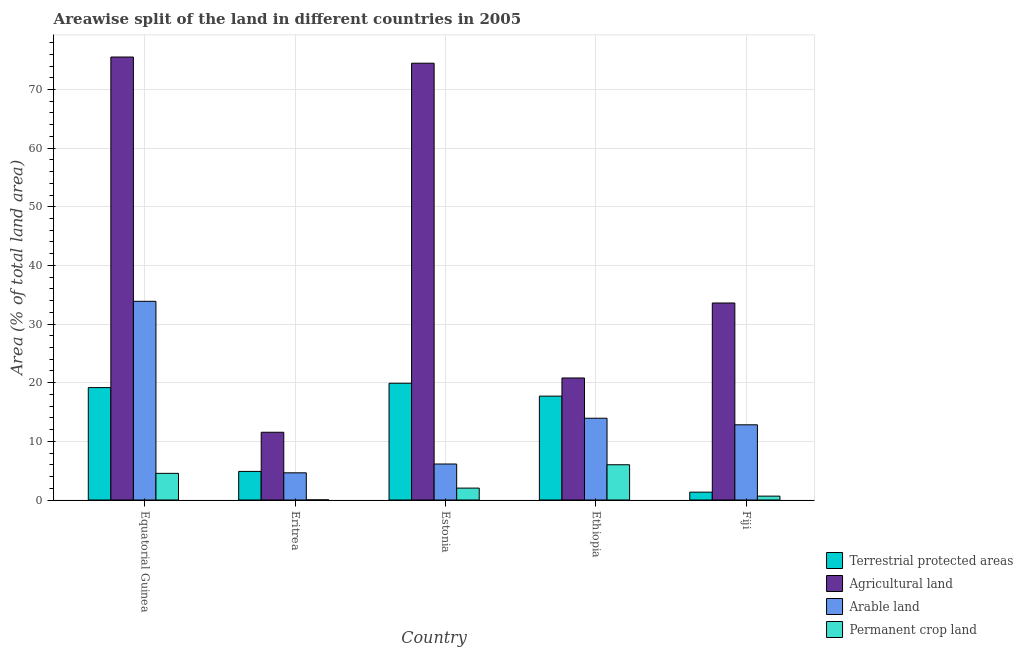How many different coloured bars are there?
Your response must be concise. 4. How many groups of bars are there?
Provide a succinct answer. 5. Are the number of bars on each tick of the X-axis equal?
Give a very brief answer. Yes. What is the label of the 4th group of bars from the left?
Give a very brief answer. Ethiopia. In how many cases, is the number of bars for a given country not equal to the number of legend labels?
Your response must be concise. 0. What is the percentage of area under permanent crop land in Fiji?
Offer a very short reply. 0.66. Across all countries, what is the maximum percentage of area under arable land?
Provide a short and direct response. 33.88. Across all countries, what is the minimum percentage of area under arable land?
Provide a short and direct response. 4.63. In which country was the percentage of land under terrestrial protection maximum?
Offer a terse response. Estonia. In which country was the percentage of area under permanent crop land minimum?
Provide a short and direct response. Eritrea. What is the total percentage of area under agricultural land in the graph?
Offer a terse response. 215.95. What is the difference between the percentage of area under agricultural land in Equatorial Guinea and that in Eritrea?
Your answer should be compact. 63.98. What is the difference between the percentage of area under permanent crop land in Fiji and the percentage of area under arable land in Equatorial Guinea?
Keep it short and to the point. -33.22. What is the average percentage of land under terrestrial protection per country?
Offer a terse response. 12.6. What is the difference between the percentage of area under arable land and percentage of area under agricultural land in Eritrea?
Give a very brief answer. -6.92. What is the ratio of the percentage of land under terrestrial protection in Eritrea to that in Ethiopia?
Your answer should be very brief. 0.28. Is the difference between the percentage of area under arable land in Estonia and Ethiopia greater than the difference between the percentage of area under agricultural land in Estonia and Ethiopia?
Offer a very short reply. No. What is the difference between the highest and the second highest percentage of area under arable land?
Keep it short and to the point. 19.94. What is the difference between the highest and the lowest percentage of area under permanent crop land?
Give a very brief answer. 6. In how many countries, is the percentage of area under permanent crop land greater than the average percentage of area under permanent crop land taken over all countries?
Your response must be concise. 2. What does the 4th bar from the left in Ethiopia represents?
Offer a terse response. Permanent crop land. What does the 3rd bar from the right in Eritrea represents?
Make the answer very short. Agricultural land. Is it the case that in every country, the sum of the percentage of land under terrestrial protection and percentage of area under agricultural land is greater than the percentage of area under arable land?
Keep it short and to the point. Yes. How many countries are there in the graph?
Keep it short and to the point. 5. Are the values on the major ticks of Y-axis written in scientific E-notation?
Your response must be concise. No. Does the graph contain any zero values?
Keep it short and to the point. No. How are the legend labels stacked?
Give a very brief answer. Vertical. What is the title of the graph?
Offer a terse response. Areawise split of the land in different countries in 2005. Does "United Kingdom" appear as one of the legend labels in the graph?
Your answer should be very brief. No. What is the label or title of the Y-axis?
Offer a very short reply. Area (% of total land area). What is the Area (% of total land area) of Terrestrial protected areas in Equatorial Guinea?
Your answer should be very brief. 19.16. What is the Area (% of total land area) of Agricultural land in Equatorial Guinea?
Offer a terse response. 75.53. What is the Area (% of total land area) in Arable land in Equatorial Guinea?
Make the answer very short. 33.88. What is the Area (% of total land area) in Permanent crop land in Equatorial Guinea?
Keep it short and to the point. 4.54. What is the Area (% of total land area) in Terrestrial protected areas in Eritrea?
Offer a terse response. 4.87. What is the Area (% of total land area) of Agricultural land in Eritrea?
Your response must be concise. 11.55. What is the Area (% of total land area) in Arable land in Eritrea?
Your answer should be very brief. 4.63. What is the Area (% of total land area) in Permanent crop land in Eritrea?
Make the answer very short. 0.01. What is the Area (% of total land area) in Terrestrial protected areas in Estonia?
Keep it short and to the point. 19.91. What is the Area (% of total land area) in Agricultural land in Estonia?
Offer a terse response. 74.48. What is the Area (% of total land area) of Arable land in Estonia?
Provide a succinct answer. 6.14. What is the Area (% of total land area) of Permanent crop land in Estonia?
Offer a terse response. 2.03. What is the Area (% of total land area) of Terrestrial protected areas in Ethiopia?
Offer a very short reply. 17.71. What is the Area (% of total land area) of Agricultural land in Ethiopia?
Ensure brevity in your answer.  20.81. What is the Area (% of total land area) of Arable land in Ethiopia?
Offer a very short reply. 13.94. What is the Area (% of total land area) in Permanent crop land in Ethiopia?
Your answer should be compact. 6.01. What is the Area (% of total land area) in Terrestrial protected areas in Fiji?
Your answer should be compact. 1.34. What is the Area (% of total land area) of Agricultural land in Fiji?
Keep it short and to the point. 33.59. What is the Area (% of total land area) of Arable land in Fiji?
Ensure brevity in your answer.  12.82. What is the Area (% of total land area) in Permanent crop land in Fiji?
Provide a succinct answer. 0.66. Across all countries, what is the maximum Area (% of total land area) of Terrestrial protected areas?
Make the answer very short. 19.91. Across all countries, what is the maximum Area (% of total land area) in Agricultural land?
Offer a terse response. 75.53. Across all countries, what is the maximum Area (% of total land area) in Arable land?
Give a very brief answer. 33.88. Across all countries, what is the maximum Area (% of total land area) in Permanent crop land?
Keep it short and to the point. 6.01. Across all countries, what is the minimum Area (% of total land area) in Terrestrial protected areas?
Your response must be concise. 1.34. Across all countries, what is the minimum Area (% of total land area) of Agricultural land?
Give a very brief answer. 11.55. Across all countries, what is the minimum Area (% of total land area) in Arable land?
Your answer should be compact. 4.63. Across all countries, what is the minimum Area (% of total land area) in Permanent crop land?
Your response must be concise. 0.01. What is the total Area (% of total land area) in Terrestrial protected areas in the graph?
Your response must be concise. 62.99. What is the total Area (% of total land area) in Agricultural land in the graph?
Make the answer very short. 215.95. What is the total Area (% of total land area) in Arable land in the graph?
Offer a terse response. 71.42. What is the total Area (% of total land area) of Permanent crop land in the graph?
Give a very brief answer. 13.26. What is the difference between the Area (% of total land area) of Terrestrial protected areas in Equatorial Guinea and that in Eritrea?
Offer a terse response. 14.29. What is the difference between the Area (% of total land area) in Agricultural land in Equatorial Guinea and that in Eritrea?
Keep it short and to the point. 63.98. What is the difference between the Area (% of total land area) in Arable land in Equatorial Guinea and that in Eritrea?
Offer a terse response. 29.25. What is the difference between the Area (% of total land area) of Permanent crop land in Equatorial Guinea and that in Eritrea?
Your answer should be very brief. 4.53. What is the difference between the Area (% of total land area) of Terrestrial protected areas in Equatorial Guinea and that in Estonia?
Your response must be concise. -0.74. What is the difference between the Area (% of total land area) of Agricultural land in Equatorial Guinea and that in Estonia?
Provide a succinct answer. 1.06. What is the difference between the Area (% of total land area) of Arable land in Equatorial Guinea and that in Estonia?
Your answer should be compact. 27.74. What is the difference between the Area (% of total land area) in Permanent crop land in Equatorial Guinea and that in Estonia?
Your response must be concise. 2.51. What is the difference between the Area (% of total land area) in Terrestrial protected areas in Equatorial Guinea and that in Ethiopia?
Provide a succinct answer. 1.45. What is the difference between the Area (% of total land area) in Agricultural land in Equatorial Guinea and that in Ethiopia?
Ensure brevity in your answer.  54.72. What is the difference between the Area (% of total land area) in Arable land in Equatorial Guinea and that in Ethiopia?
Keep it short and to the point. 19.94. What is the difference between the Area (% of total land area) of Permanent crop land in Equatorial Guinea and that in Ethiopia?
Provide a short and direct response. -1.47. What is the difference between the Area (% of total land area) in Terrestrial protected areas in Equatorial Guinea and that in Fiji?
Make the answer very short. 17.83. What is the difference between the Area (% of total land area) of Agricultural land in Equatorial Guinea and that in Fiji?
Provide a succinct answer. 41.94. What is the difference between the Area (% of total land area) in Arable land in Equatorial Guinea and that in Fiji?
Offer a terse response. 21.06. What is the difference between the Area (% of total land area) of Permanent crop land in Equatorial Guinea and that in Fiji?
Your answer should be compact. 3.88. What is the difference between the Area (% of total land area) in Terrestrial protected areas in Eritrea and that in Estonia?
Give a very brief answer. -15.03. What is the difference between the Area (% of total land area) of Agricultural land in Eritrea and that in Estonia?
Your answer should be compact. -62.92. What is the difference between the Area (% of total land area) of Arable land in Eritrea and that in Estonia?
Keep it short and to the point. -1.5. What is the difference between the Area (% of total land area) of Permanent crop land in Eritrea and that in Estonia?
Your response must be concise. -2.01. What is the difference between the Area (% of total land area) of Terrestrial protected areas in Eritrea and that in Ethiopia?
Make the answer very short. -12.84. What is the difference between the Area (% of total land area) in Agricultural land in Eritrea and that in Ethiopia?
Keep it short and to the point. -9.26. What is the difference between the Area (% of total land area) in Arable land in Eritrea and that in Ethiopia?
Provide a short and direct response. -9.31. What is the difference between the Area (% of total land area) of Permanent crop land in Eritrea and that in Ethiopia?
Offer a terse response. -6. What is the difference between the Area (% of total land area) of Terrestrial protected areas in Eritrea and that in Fiji?
Offer a terse response. 3.54. What is the difference between the Area (% of total land area) in Agricultural land in Eritrea and that in Fiji?
Provide a short and direct response. -22.04. What is the difference between the Area (% of total land area) in Arable land in Eritrea and that in Fiji?
Make the answer very short. -8.19. What is the difference between the Area (% of total land area) of Permanent crop land in Eritrea and that in Fiji?
Your answer should be very brief. -0.65. What is the difference between the Area (% of total land area) in Terrestrial protected areas in Estonia and that in Ethiopia?
Your answer should be very brief. 2.2. What is the difference between the Area (% of total land area) in Agricultural land in Estonia and that in Ethiopia?
Keep it short and to the point. 53.67. What is the difference between the Area (% of total land area) of Arable land in Estonia and that in Ethiopia?
Provide a short and direct response. -7.8. What is the difference between the Area (% of total land area) of Permanent crop land in Estonia and that in Ethiopia?
Your answer should be very brief. -3.98. What is the difference between the Area (% of total land area) of Terrestrial protected areas in Estonia and that in Fiji?
Ensure brevity in your answer.  18.57. What is the difference between the Area (% of total land area) of Agricultural land in Estonia and that in Fiji?
Provide a short and direct response. 40.88. What is the difference between the Area (% of total land area) in Arable land in Estonia and that in Fiji?
Provide a succinct answer. -6.68. What is the difference between the Area (% of total land area) in Permanent crop land in Estonia and that in Fiji?
Offer a terse response. 1.37. What is the difference between the Area (% of total land area) in Terrestrial protected areas in Ethiopia and that in Fiji?
Offer a very short reply. 16.37. What is the difference between the Area (% of total land area) in Agricultural land in Ethiopia and that in Fiji?
Your answer should be compact. -12.78. What is the difference between the Area (% of total land area) in Arable land in Ethiopia and that in Fiji?
Your answer should be compact. 1.12. What is the difference between the Area (% of total land area) in Permanent crop land in Ethiopia and that in Fiji?
Make the answer very short. 5.35. What is the difference between the Area (% of total land area) in Terrestrial protected areas in Equatorial Guinea and the Area (% of total land area) in Agricultural land in Eritrea?
Your answer should be very brief. 7.61. What is the difference between the Area (% of total land area) of Terrestrial protected areas in Equatorial Guinea and the Area (% of total land area) of Arable land in Eritrea?
Provide a short and direct response. 14.53. What is the difference between the Area (% of total land area) of Terrestrial protected areas in Equatorial Guinea and the Area (% of total land area) of Permanent crop land in Eritrea?
Make the answer very short. 19.15. What is the difference between the Area (% of total land area) in Agricultural land in Equatorial Guinea and the Area (% of total land area) in Arable land in Eritrea?
Keep it short and to the point. 70.9. What is the difference between the Area (% of total land area) in Agricultural land in Equatorial Guinea and the Area (% of total land area) in Permanent crop land in Eritrea?
Make the answer very short. 75.52. What is the difference between the Area (% of total land area) in Arable land in Equatorial Guinea and the Area (% of total land area) in Permanent crop land in Eritrea?
Offer a terse response. 33.87. What is the difference between the Area (% of total land area) in Terrestrial protected areas in Equatorial Guinea and the Area (% of total land area) in Agricultural land in Estonia?
Offer a terse response. -55.31. What is the difference between the Area (% of total land area) of Terrestrial protected areas in Equatorial Guinea and the Area (% of total land area) of Arable land in Estonia?
Offer a terse response. 13.03. What is the difference between the Area (% of total land area) of Terrestrial protected areas in Equatorial Guinea and the Area (% of total land area) of Permanent crop land in Estonia?
Your answer should be compact. 17.14. What is the difference between the Area (% of total land area) in Agricultural land in Equatorial Guinea and the Area (% of total land area) in Arable land in Estonia?
Provide a succinct answer. 69.39. What is the difference between the Area (% of total land area) of Agricultural land in Equatorial Guinea and the Area (% of total land area) of Permanent crop land in Estonia?
Offer a very short reply. 73.5. What is the difference between the Area (% of total land area) of Arable land in Equatorial Guinea and the Area (% of total land area) of Permanent crop land in Estonia?
Your answer should be compact. 31.85. What is the difference between the Area (% of total land area) in Terrestrial protected areas in Equatorial Guinea and the Area (% of total land area) in Agricultural land in Ethiopia?
Your answer should be very brief. -1.64. What is the difference between the Area (% of total land area) in Terrestrial protected areas in Equatorial Guinea and the Area (% of total land area) in Arable land in Ethiopia?
Provide a succinct answer. 5.22. What is the difference between the Area (% of total land area) of Terrestrial protected areas in Equatorial Guinea and the Area (% of total land area) of Permanent crop land in Ethiopia?
Your answer should be compact. 13.15. What is the difference between the Area (% of total land area) of Agricultural land in Equatorial Guinea and the Area (% of total land area) of Arable land in Ethiopia?
Ensure brevity in your answer.  61.59. What is the difference between the Area (% of total land area) in Agricultural land in Equatorial Guinea and the Area (% of total land area) in Permanent crop land in Ethiopia?
Provide a succinct answer. 69.52. What is the difference between the Area (% of total land area) of Arable land in Equatorial Guinea and the Area (% of total land area) of Permanent crop land in Ethiopia?
Keep it short and to the point. 27.87. What is the difference between the Area (% of total land area) of Terrestrial protected areas in Equatorial Guinea and the Area (% of total land area) of Agricultural land in Fiji?
Offer a terse response. -14.43. What is the difference between the Area (% of total land area) in Terrestrial protected areas in Equatorial Guinea and the Area (% of total land area) in Arable land in Fiji?
Ensure brevity in your answer.  6.34. What is the difference between the Area (% of total land area) of Terrestrial protected areas in Equatorial Guinea and the Area (% of total land area) of Permanent crop land in Fiji?
Your response must be concise. 18.5. What is the difference between the Area (% of total land area) in Agricultural land in Equatorial Guinea and the Area (% of total land area) in Arable land in Fiji?
Ensure brevity in your answer.  62.71. What is the difference between the Area (% of total land area) in Agricultural land in Equatorial Guinea and the Area (% of total land area) in Permanent crop land in Fiji?
Make the answer very short. 74.87. What is the difference between the Area (% of total land area) of Arable land in Equatorial Guinea and the Area (% of total land area) of Permanent crop land in Fiji?
Provide a succinct answer. 33.22. What is the difference between the Area (% of total land area) in Terrestrial protected areas in Eritrea and the Area (% of total land area) in Agricultural land in Estonia?
Ensure brevity in your answer.  -69.6. What is the difference between the Area (% of total land area) of Terrestrial protected areas in Eritrea and the Area (% of total land area) of Arable land in Estonia?
Offer a very short reply. -1.26. What is the difference between the Area (% of total land area) of Terrestrial protected areas in Eritrea and the Area (% of total land area) of Permanent crop land in Estonia?
Offer a very short reply. 2.85. What is the difference between the Area (% of total land area) of Agricultural land in Eritrea and the Area (% of total land area) of Arable land in Estonia?
Offer a very short reply. 5.41. What is the difference between the Area (% of total land area) in Agricultural land in Eritrea and the Area (% of total land area) in Permanent crop land in Estonia?
Provide a succinct answer. 9.52. What is the difference between the Area (% of total land area) in Arable land in Eritrea and the Area (% of total land area) in Permanent crop land in Estonia?
Your answer should be very brief. 2.61. What is the difference between the Area (% of total land area) of Terrestrial protected areas in Eritrea and the Area (% of total land area) of Agricultural land in Ethiopia?
Give a very brief answer. -15.93. What is the difference between the Area (% of total land area) of Terrestrial protected areas in Eritrea and the Area (% of total land area) of Arable land in Ethiopia?
Ensure brevity in your answer.  -9.07. What is the difference between the Area (% of total land area) of Terrestrial protected areas in Eritrea and the Area (% of total land area) of Permanent crop land in Ethiopia?
Offer a terse response. -1.14. What is the difference between the Area (% of total land area) of Agricultural land in Eritrea and the Area (% of total land area) of Arable land in Ethiopia?
Keep it short and to the point. -2.39. What is the difference between the Area (% of total land area) in Agricultural land in Eritrea and the Area (% of total land area) in Permanent crop land in Ethiopia?
Your answer should be very brief. 5.54. What is the difference between the Area (% of total land area) of Arable land in Eritrea and the Area (% of total land area) of Permanent crop land in Ethiopia?
Ensure brevity in your answer.  -1.38. What is the difference between the Area (% of total land area) in Terrestrial protected areas in Eritrea and the Area (% of total land area) in Agricultural land in Fiji?
Keep it short and to the point. -28.72. What is the difference between the Area (% of total land area) in Terrestrial protected areas in Eritrea and the Area (% of total land area) in Arable land in Fiji?
Your answer should be very brief. -7.95. What is the difference between the Area (% of total land area) of Terrestrial protected areas in Eritrea and the Area (% of total land area) of Permanent crop land in Fiji?
Give a very brief answer. 4.21. What is the difference between the Area (% of total land area) in Agricultural land in Eritrea and the Area (% of total land area) in Arable land in Fiji?
Provide a short and direct response. -1.27. What is the difference between the Area (% of total land area) in Agricultural land in Eritrea and the Area (% of total land area) in Permanent crop land in Fiji?
Offer a very short reply. 10.89. What is the difference between the Area (% of total land area) of Arable land in Eritrea and the Area (% of total land area) of Permanent crop land in Fiji?
Provide a short and direct response. 3.97. What is the difference between the Area (% of total land area) of Terrestrial protected areas in Estonia and the Area (% of total land area) of Agricultural land in Ethiopia?
Offer a very short reply. -0.9. What is the difference between the Area (% of total land area) in Terrestrial protected areas in Estonia and the Area (% of total land area) in Arable land in Ethiopia?
Your answer should be very brief. 5.97. What is the difference between the Area (% of total land area) of Terrestrial protected areas in Estonia and the Area (% of total land area) of Permanent crop land in Ethiopia?
Offer a very short reply. 13.9. What is the difference between the Area (% of total land area) in Agricultural land in Estonia and the Area (% of total land area) in Arable land in Ethiopia?
Offer a terse response. 60.53. What is the difference between the Area (% of total land area) of Agricultural land in Estonia and the Area (% of total land area) of Permanent crop land in Ethiopia?
Your answer should be very brief. 68.46. What is the difference between the Area (% of total land area) of Arable land in Estonia and the Area (% of total land area) of Permanent crop land in Ethiopia?
Your answer should be very brief. 0.13. What is the difference between the Area (% of total land area) in Terrestrial protected areas in Estonia and the Area (% of total land area) in Agricultural land in Fiji?
Your answer should be compact. -13.68. What is the difference between the Area (% of total land area) of Terrestrial protected areas in Estonia and the Area (% of total land area) of Arable land in Fiji?
Your response must be concise. 7.08. What is the difference between the Area (% of total land area) of Terrestrial protected areas in Estonia and the Area (% of total land area) of Permanent crop land in Fiji?
Provide a short and direct response. 19.25. What is the difference between the Area (% of total land area) of Agricultural land in Estonia and the Area (% of total land area) of Arable land in Fiji?
Your answer should be very brief. 61.65. What is the difference between the Area (% of total land area) of Agricultural land in Estonia and the Area (% of total land area) of Permanent crop land in Fiji?
Make the answer very short. 73.82. What is the difference between the Area (% of total land area) in Arable land in Estonia and the Area (% of total land area) in Permanent crop land in Fiji?
Your response must be concise. 5.48. What is the difference between the Area (% of total land area) of Terrestrial protected areas in Ethiopia and the Area (% of total land area) of Agricultural land in Fiji?
Make the answer very short. -15.88. What is the difference between the Area (% of total land area) of Terrestrial protected areas in Ethiopia and the Area (% of total land area) of Arable land in Fiji?
Your response must be concise. 4.89. What is the difference between the Area (% of total land area) in Terrestrial protected areas in Ethiopia and the Area (% of total land area) in Permanent crop land in Fiji?
Your response must be concise. 17.05. What is the difference between the Area (% of total land area) of Agricultural land in Ethiopia and the Area (% of total land area) of Arable land in Fiji?
Offer a terse response. 7.98. What is the difference between the Area (% of total land area) of Agricultural land in Ethiopia and the Area (% of total land area) of Permanent crop land in Fiji?
Your answer should be very brief. 20.15. What is the difference between the Area (% of total land area) in Arable land in Ethiopia and the Area (% of total land area) in Permanent crop land in Fiji?
Offer a very short reply. 13.28. What is the average Area (% of total land area) in Terrestrial protected areas per country?
Provide a short and direct response. 12.6. What is the average Area (% of total land area) in Agricultural land per country?
Your answer should be very brief. 43.19. What is the average Area (% of total land area) of Arable land per country?
Offer a very short reply. 14.28. What is the average Area (% of total land area) of Permanent crop land per country?
Your answer should be very brief. 2.65. What is the difference between the Area (% of total land area) of Terrestrial protected areas and Area (% of total land area) of Agricultural land in Equatorial Guinea?
Keep it short and to the point. -56.37. What is the difference between the Area (% of total land area) of Terrestrial protected areas and Area (% of total land area) of Arable land in Equatorial Guinea?
Your answer should be very brief. -14.72. What is the difference between the Area (% of total land area) in Terrestrial protected areas and Area (% of total land area) in Permanent crop land in Equatorial Guinea?
Offer a very short reply. 14.62. What is the difference between the Area (% of total land area) in Agricultural land and Area (% of total land area) in Arable land in Equatorial Guinea?
Provide a succinct answer. 41.65. What is the difference between the Area (% of total land area) of Agricultural land and Area (% of total land area) of Permanent crop land in Equatorial Guinea?
Your answer should be very brief. 70.99. What is the difference between the Area (% of total land area) of Arable land and Area (% of total land area) of Permanent crop land in Equatorial Guinea?
Give a very brief answer. 29.34. What is the difference between the Area (% of total land area) in Terrestrial protected areas and Area (% of total land area) in Agricultural land in Eritrea?
Your response must be concise. -6.68. What is the difference between the Area (% of total land area) in Terrestrial protected areas and Area (% of total land area) in Arable land in Eritrea?
Provide a short and direct response. 0.24. What is the difference between the Area (% of total land area) in Terrestrial protected areas and Area (% of total land area) in Permanent crop land in Eritrea?
Your answer should be very brief. 4.86. What is the difference between the Area (% of total land area) of Agricultural land and Area (% of total land area) of Arable land in Eritrea?
Provide a short and direct response. 6.92. What is the difference between the Area (% of total land area) in Agricultural land and Area (% of total land area) in Permanent crop land in Eritrea?
Make the answer very short. 11.54. What is the difference between the Area (% of total land area) of Arable land and Area (% of total land area) of Permanent crop land in Eritrea?
Your answer should be compact. 4.62. What is the difference between the Area (% of total land area) in Terrestrial protected areas and Area (% of total land area) in Agricultural land in Estonia?
Offer a very short reply. -54.57. What is the difference between the Area (% of total land area) of Terrestrial protected areas and Area (% of total land area) of Arable land in Estonia?
Your answer should be compact. 13.77. What is the difference between the Area (% of total land area) in Terrestrial protected areas and Area (% of total land area) in Permanent crop land in Estonia?
Your response must be concise. 17.88. What is the difference between the Area (% of total land area) of Agricultural land and Area (% of total land area) of Arable land in Estonia?
Offer a very short reply. 68.34. What is the difference between the Area (% of total land area) of Agricultural land and Area (% of total land area) of Permanent crop land in Estonia?
Your answer should be very brief. 72.45. What is the difference between the Area (% of total land area) in Arable land and Area (% of total land area) in Permanent crop land in Estonia?
Provide a short and direct response. 4.11. What is the difference between the Area (% of total land area) in Terrestrial protected areas and Area (% of total land area) in Agricultural land in Ethiopia?
Provide a succinct answer. -3.1. What is the difference between the Area (% of total land area) of Terrestrial protected areas and Area (% of total land area) of Arable land in Ethiopia?
Make the answer very short. 3.77. What is the difference between the Area (% of total land area) in Terrestrial protected areas and Area (% of total land area) in Permanent crop land in Ethiopia?
Your answer should be compact. 11.7. What is the difference between the Area (% of total land area) in Agricultural land and Area (% of total land area) in Arable land in Ethiopia?
Your answer should be very brief. 6.86. What is the difference between the Area (% of total land area) of Agricultural land and Area (% of total land area) of Permanent crop land in Ethiopia?
Provide a succinct answer. 14.8. What is the difference between the Area (% of total land area) of Arable land and Area (% of total land area) of Permanent crop land in Ethiopia?
Give a very brief answer. 7.93. What is the difference between the Area (% of total land area) of Terrestrial protected areas and Area (% of total land area) of Agricultural land in Fiji?
Offer a very short reply. -32.25. What is the difference between the Area (% of total land area) in Terrestrial protected areas and Area (% of total land area) in Arable land in Fiji?
Your response must be concise. -11.48. What is the difference between the Area (% of total land area) of Terrestrial protected areas and Area (% of total land area) of Permanent crop land in Fiji?
Keep it short and to the point. 0.68. What is the difference between the Area (% of total land area) in Agricultural land and Area (% of total land area) in Arable land in Fiji?
Provide a short and direct response. 20.77. What is the difference between the Area (% of total land area) of Agricultural land and Area (% of total land area) of Permanent crop land in Fiji?
Offer a terse response. 32.93. What is the difference between the Area (% of total land area) of Arable land and Area (% of total land area) of Permanent crop land in Fiji?
Make the answer very short. 12.16. What is the ratio of the Area (% of total land area) of Terrestrial protected areas in Equatorial Guinea to that in Eritrea?
Provide a succinct answer. 3.93. What is the ratio of the Area (% of total land area) in Agricultural land in Equatorial Guinea to that in Eritrea?
Offer a terse response. 6.54. What is the ratio of the Area (% of total land area) of Arable land in Equatorial Guinea to that in Eritrea?
Give a very brief answer. 7.31. What is the ratio of the Area (% of total land area) of Permanent crop land in Equatorial Guinea to that in Eritrea?
Keep it short and to the point. 321.8. What is the ratio of the Area (% of total land area) in Terrestrial protected areas in Equatorial Guinea to that in Estonia?
Provide a short and direct response. 0.96. What is the ratio of the Area (% of total land area) of Agricultural land in Equatorial Guinea to that in Estonia?
Give a very brief answer. 1.01. What is the ratio of the Area (% of total land area) in Arable land in Equatorial Guinea to that in Estonia?
Offer a terse response. 5.52. What is the ratio of the Area (% of total land area) in Permanent crop land in Equatorial Guinea to that in Estonia?
Give a very brief answer. 2.24. What is the ratio of the Area (% of total land area) of Terrestrial protected areas in Equatorial Guinea to that in Ethiopia?
Keep it short and to the point. 1.08. What is the ratio of the Area (% of total land area) of Agricultural land in Equatorial Guinea to that in Ethiopia?
Your response must be concise. 3.63. What is the ratio of the Area (% of total land area) of Arable land in Equatorial Guinea to that in Ethiopia?
Offer a very short reply. 2.43. What is the ratio of the Area (% of total land area) in Permanent crop land in Equatorial Guinea to that in Ethiopia?
Offer a terse response. 0.76. What is the ratio of the Area (% of total land area) of Terrestrial protected areas in Equatorial Guinea to that in Fiji?
Offer a very short reply. 14.31. What is the ratio of the Area (% of total land area) in Agricultural land in Equatorial Guinea to that in Fiji?
Your response must be concise. 2.25. What is the ratio of the Area (% of total land area) of Arable land in Equatorial Guinea to that in Fiji?
Your response must be concise. 2.64. What is the ratio of the Area (% of total land area) of Permanent crop land in Equatorial Guinea to that in Fiji?
Your response must be concise. 6.89. What is the ratio of the Area (% of total land area) in Terrestrial protected areas in Eritrea to that in Estonia?
Your answer should be compact. 0.24. What is the ratio of the Area (% of total land area) in Agricultural land in Eritrea to that in Estonia?
Make the answer very short. 0.16. What is the ratio of the Area (% of total land area) of Arable land in Eritrea to that in Estonia?
Give a very brief answer. 0.76. What is the ratio of the Area (% of total land area) in Permanent crop land in Eritrea to that in Estonia?
Offer a very short reply. 0.01. What is the ratio of the Area (% of total land area) in Terrestrial protected areas in Eritrea to that in Ethiopia?
Give a very brief answer. 0.28. What is the ratio of the Area (% of total land area) in Agricultural land in Eritrea to that in Ethiopia?
Your response must be concise. 0.56. What is the ratio of the Area (% of total land area) in Arable land in Eritrea to that in Ethiopia?
Your answer should be compact. 0.33. What is the ratio of the Area (% of total land area) of Permanent crop land in Eritrea to that in Ethiopia?
Provide a short and direct response. 0. What is the ratio of the Area (% of total land area) in Terrestrial protected areas in Eritrea to that in Fiji?
Your answer should be very brief. 3.64. What is the ratio of the Area (% of total land area) in Agricultural land in Eritrea to that in Fiji?
Provide a succinct answer. 0.34. What is the ratio of the Area (% of total land area) in Arable land in Eritrea to that in Fiji?
Give a very brief answer. 0.36. What is the ratio of the Area (% of total land area) in Permanent crop land in Eritrea to that in Fiji?
Provide a short and direct response. 0.02. What is the ratio of the Area (% of total land area) of Terrestrial protected areas in Estonia to that in Ethiopia?
Your answer should be compact. 1.12. What is the ratio of the Area (% of total land area) in Agricultural land in Estonia to that in Ethiopia?
Offer a very short reply. 3.58. What is the ratio of the Area (% of total land area) of Arable land in Estonia to that in Ethiopia?
Ensure brevity in your answer.  0.44. What is the ratio of the Area (% of total land area) in Permanent crop land in Estonia to that in Ethiopia?
Give a very brief answer. 0.34. What is the ratio of the Area (% of total land area) in Terrestrial protected areas in Estonia to that in Fiji?
Your answer should be compact. 14.87. What is the ratio of the Area (% of total land area) in Agricultural land in Estonia to that in Fiji?
Your answer should be very brief. 2.22. What is the ratio of the Area (% of total land area) in Arable land in Estonia to that in Fiji?
Make the answer very short. 0.48. What is the ratio of the Area (% of total land area) of Permanent crop land in Estonia to that in Fiji?
Provide a succinct answer. 3.07. What is the ratio of the Area (% of total land area) in Terrestrial protected areas in Ethiopia to that in Fiji?
Ensure brevity in your answer.  13.23. What is the ratio of the Area (% of total land area) of Agricultural land in Ethiopia to that in Fiji?
Give a very brief answer. 0.62. What is the ratio of the Area (% of total land area) in Arable land in Ethiopia to that in Fiji?
Offer a terse response. 1.09. What is the ratio of the Area (% of total land area) in Permanent crop land in Ethiopia to that in Fiji?
Make the answer very short. 9.11. What is the difference between the highest and the second highest Area (% of total land area) of Terrestrial protected areas?
Ensure brevity in your answer.  0.74. What is the difference between the highest and the second highest Area (% of total land area) in Agricultural land?
Your answer should be very brief. 1.06. What is the difference between the highest and the second highest Area (% of total land area) of Arable land?
Keep it short and to the point. 19.94. What is the difference between the highest and the second highest Area (% of total land area) of Permanent crop land?
Your answer should be compact. 1.47. What is the difference between the highest and the lowest Area (% of total land area) of Terrestrial protected areas?
Offer a terse response. 18.57. What is the difference between the highest and the lowest Area (% of total land area) of Agricultural land?
Your response must be concise. 63.98. What is the difference between the highest and the lowest Area (% of total land area) in Arable land?
Make the answer very short. 29.25. What is the difference between the highest and the lowest Area (% of total land area) of Permanent crop land?
Your answer should be very brief. 6. 